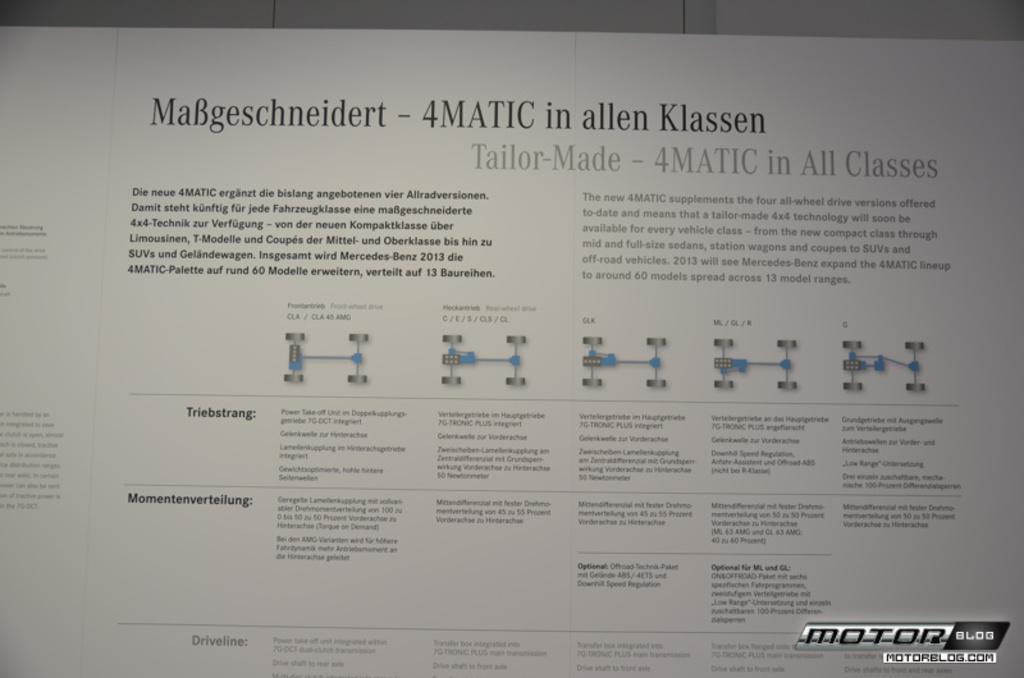How would you summarize this image in a sentence or two? In this image we can see a white descriptive board. There is a text at the bottom of the image. 